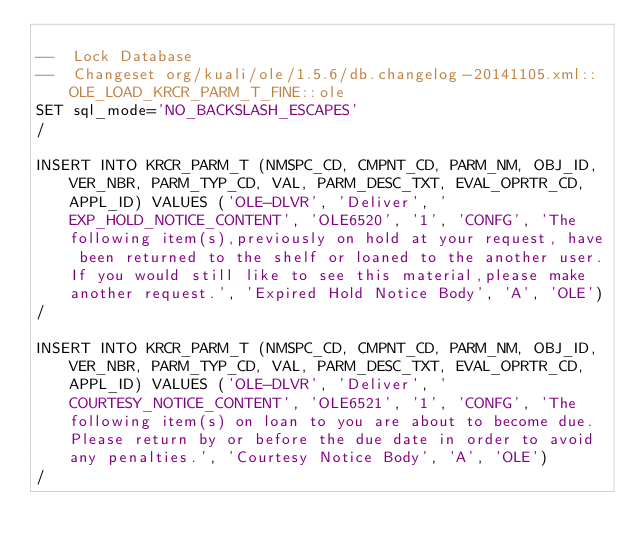<code> <loc_0><loc_0><loc_500><loc_500><_SQL_>
--  Lock Database
--  Changeset org/kuali/ole/1.5.6/db.changelog-20141105.xml::OLE_LOAD_KRCR_PARM_T_FINE::ole
SET sql_mode='NO_BACKSLASH_ESCAPES'
/

INSERT INTO KRCR_PARM_T (NMSPC_CD, CMPNT_CD, PARM_NM, OBJ_ID, VER_NBR, PARM_TYP_CD, VAL, PARM_DESC_TXT, EVAL_OPRTR_CD, APPL_ID) VALUES ('OLE-DLVR', 'Deliver', 'EXP_HOLD_NOTICE_CONTENT', 'OLE6520', '1', 'CONFG', 'The following item(s),previously on hold at your request, have been returned to the shelf or loaned to the another user.If you would still like to see this material,please make another request.', 'Expired Hold Notice Body', 'A', 'OLE')
/

INSERT INTO KRCR_PARM_T (NMSPC_CD, CMPNT_CD, PARM_NM, OBJ_ID, VER_NBR, PARM_TYP_CD, VAL, PARM_DESC_TXT, EVAL_OPRTR_CD, APPL_ID) VALUES ('OLE-DLVR', 'Deliver', 'COURTESY_NOTICE_CONTENT', 'OLE6521', '1', 'CONFG', 'The following item(s) on loan to you are about to become due. Please return by or before the due date in order to avoid any penalties.', 'Courtesy Notice Body', 'A', 'OLE')
/
</code> 